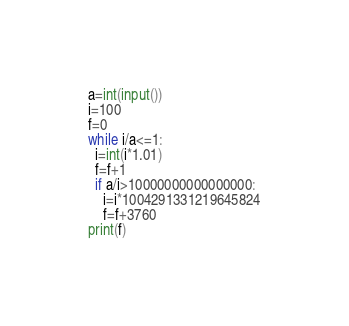Convert code to text. <code><loc_0><loc_0><loc_500><loc_500><_Python_>a=int(input())
i=100
f=0
while i/a<=1:
  i=int(i*1.01)
  f=f+1
  if a/i>10000000000000000:
    i=i*1004291331219645824
    f=f+3760
print(f)</code> 